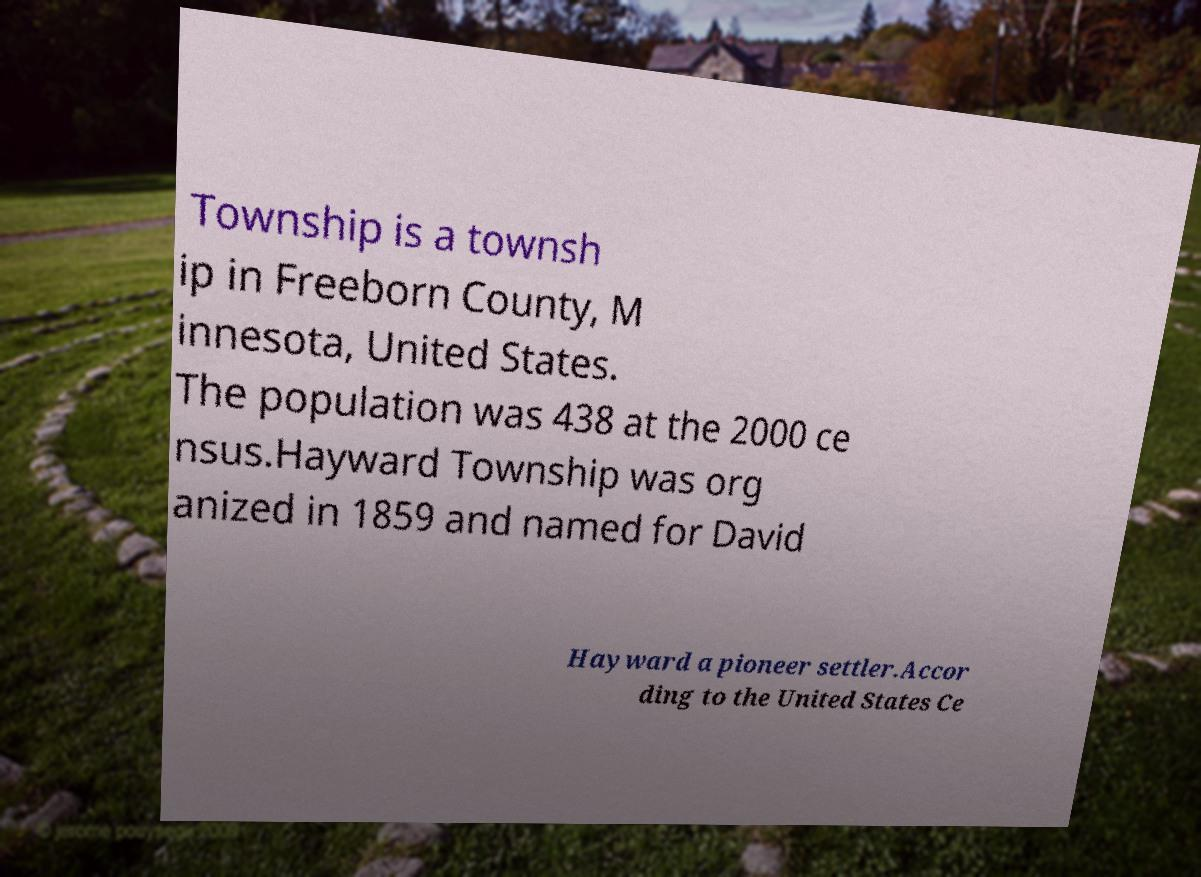There's text embedded in this image that I need extracted. Can you transcribe it verbatim? Township is a townsh ip in Freeborn County, M innesota, United States. The population was 438 at the 2000 ce nsus.Hayward Township was org anized in 1859 and named for David Hayward a pioneer settler.Accor ding to the United States Ce 